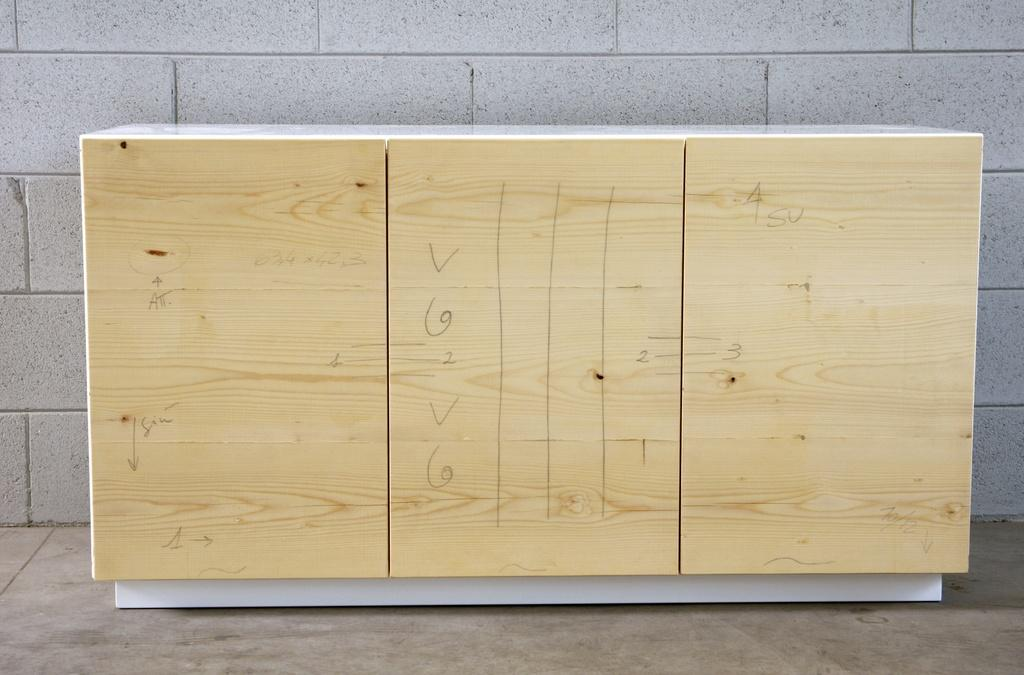What is the main object in the center of the image? There is a board in the center of the image. What can be seen on the board? There is text written on the board. What is visible behind the board? There is a wall in the background of the image. What is the surface beneath the board? There is a floor at the bottom of the image. Can you hear the whistle in the image? There is no whistle present in the image, so it cannot be heard. 